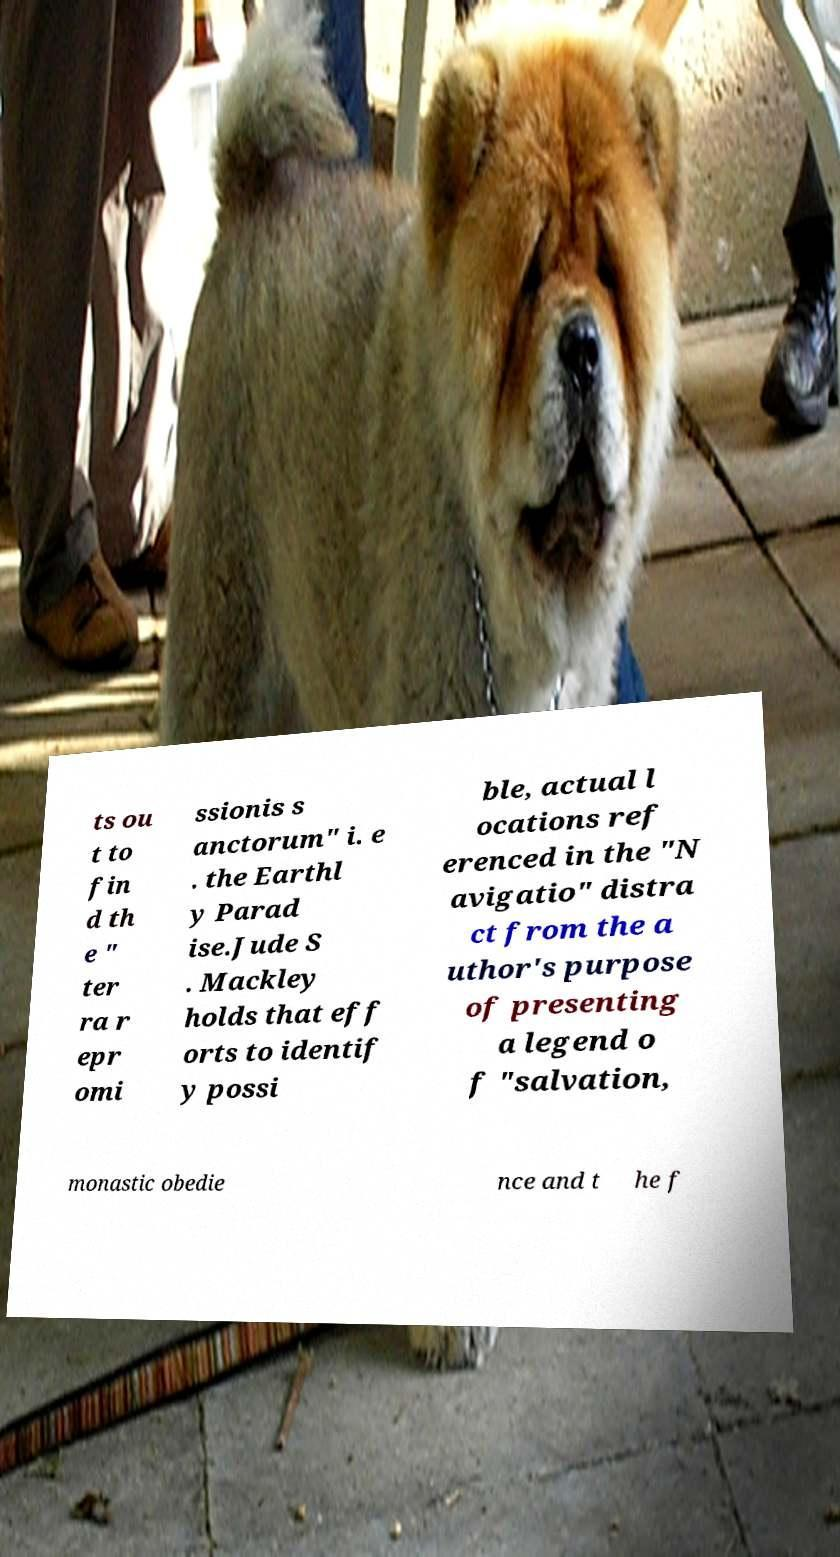Can you read and provide the text displayed in the image?This photo seems to have some interesting text. Can you extract and type it out for me? ts ou t to fin d th e " ter ra r epr omi ssionis s anctorum" i. e . the Earthl y Parad ise.Jude S . Mackley holds that eff orts to identif y possi ble, actual l ocations ref erenced in the "N avigatio" distra ct from the a uthor's purpose of presenting a legend o f "salvation, monastic obedie nce and t he f 